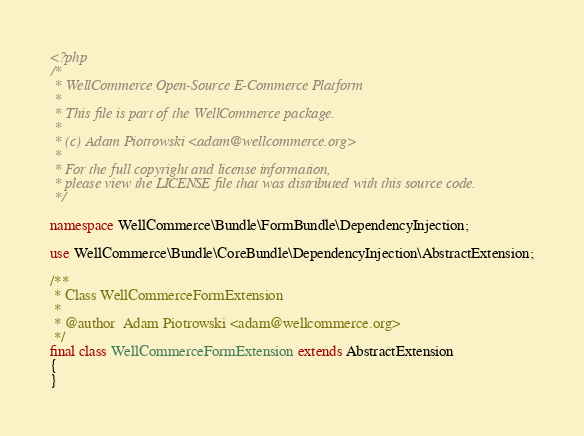Convert code to text. <code><loc_0><loc_0><loc_500><loc_500><_PHP_><?php
/*
 * WellCommerce Open-Source E-Commerce Platform
 *
 * This file is part of the WellCommerce package.
 *
 * (c) Adam Piotrowski <adam@wellcommerce.org>
 *
 * For the full copyright and license information,
 * please view the LICENSE file that was distributed with this source code.
 */

namespace WellCommerce\Bundle\FormBundle\DependencyInjection;

use WellCommerce\Bundle\CoreBundle\DependencyInjection\AbstractExtension;

/**
 * Class WellCommerceFormExtension
 *
 * @author  Adam Piotrowski <adam@wellcommerce.org>
 */
final class WellCommerceFormExtension extends AbstractExtension
{
}
</code> 